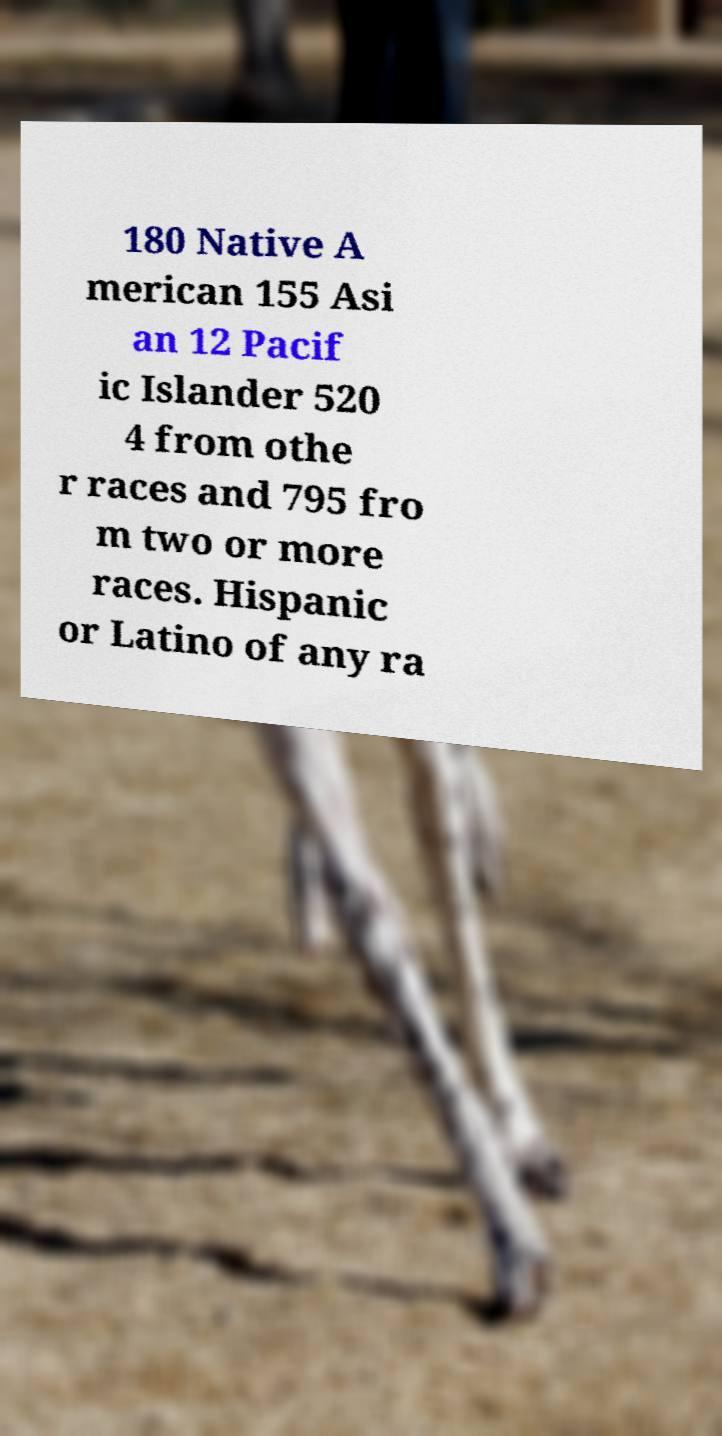Please read and relay the text visible in this image. What does it say? 180 Native A merican 155 Asi an 12 Pacif ic Islander 520 4 from othe r races and 795 fro m two or more races. Hispanic or Latino of any ra 